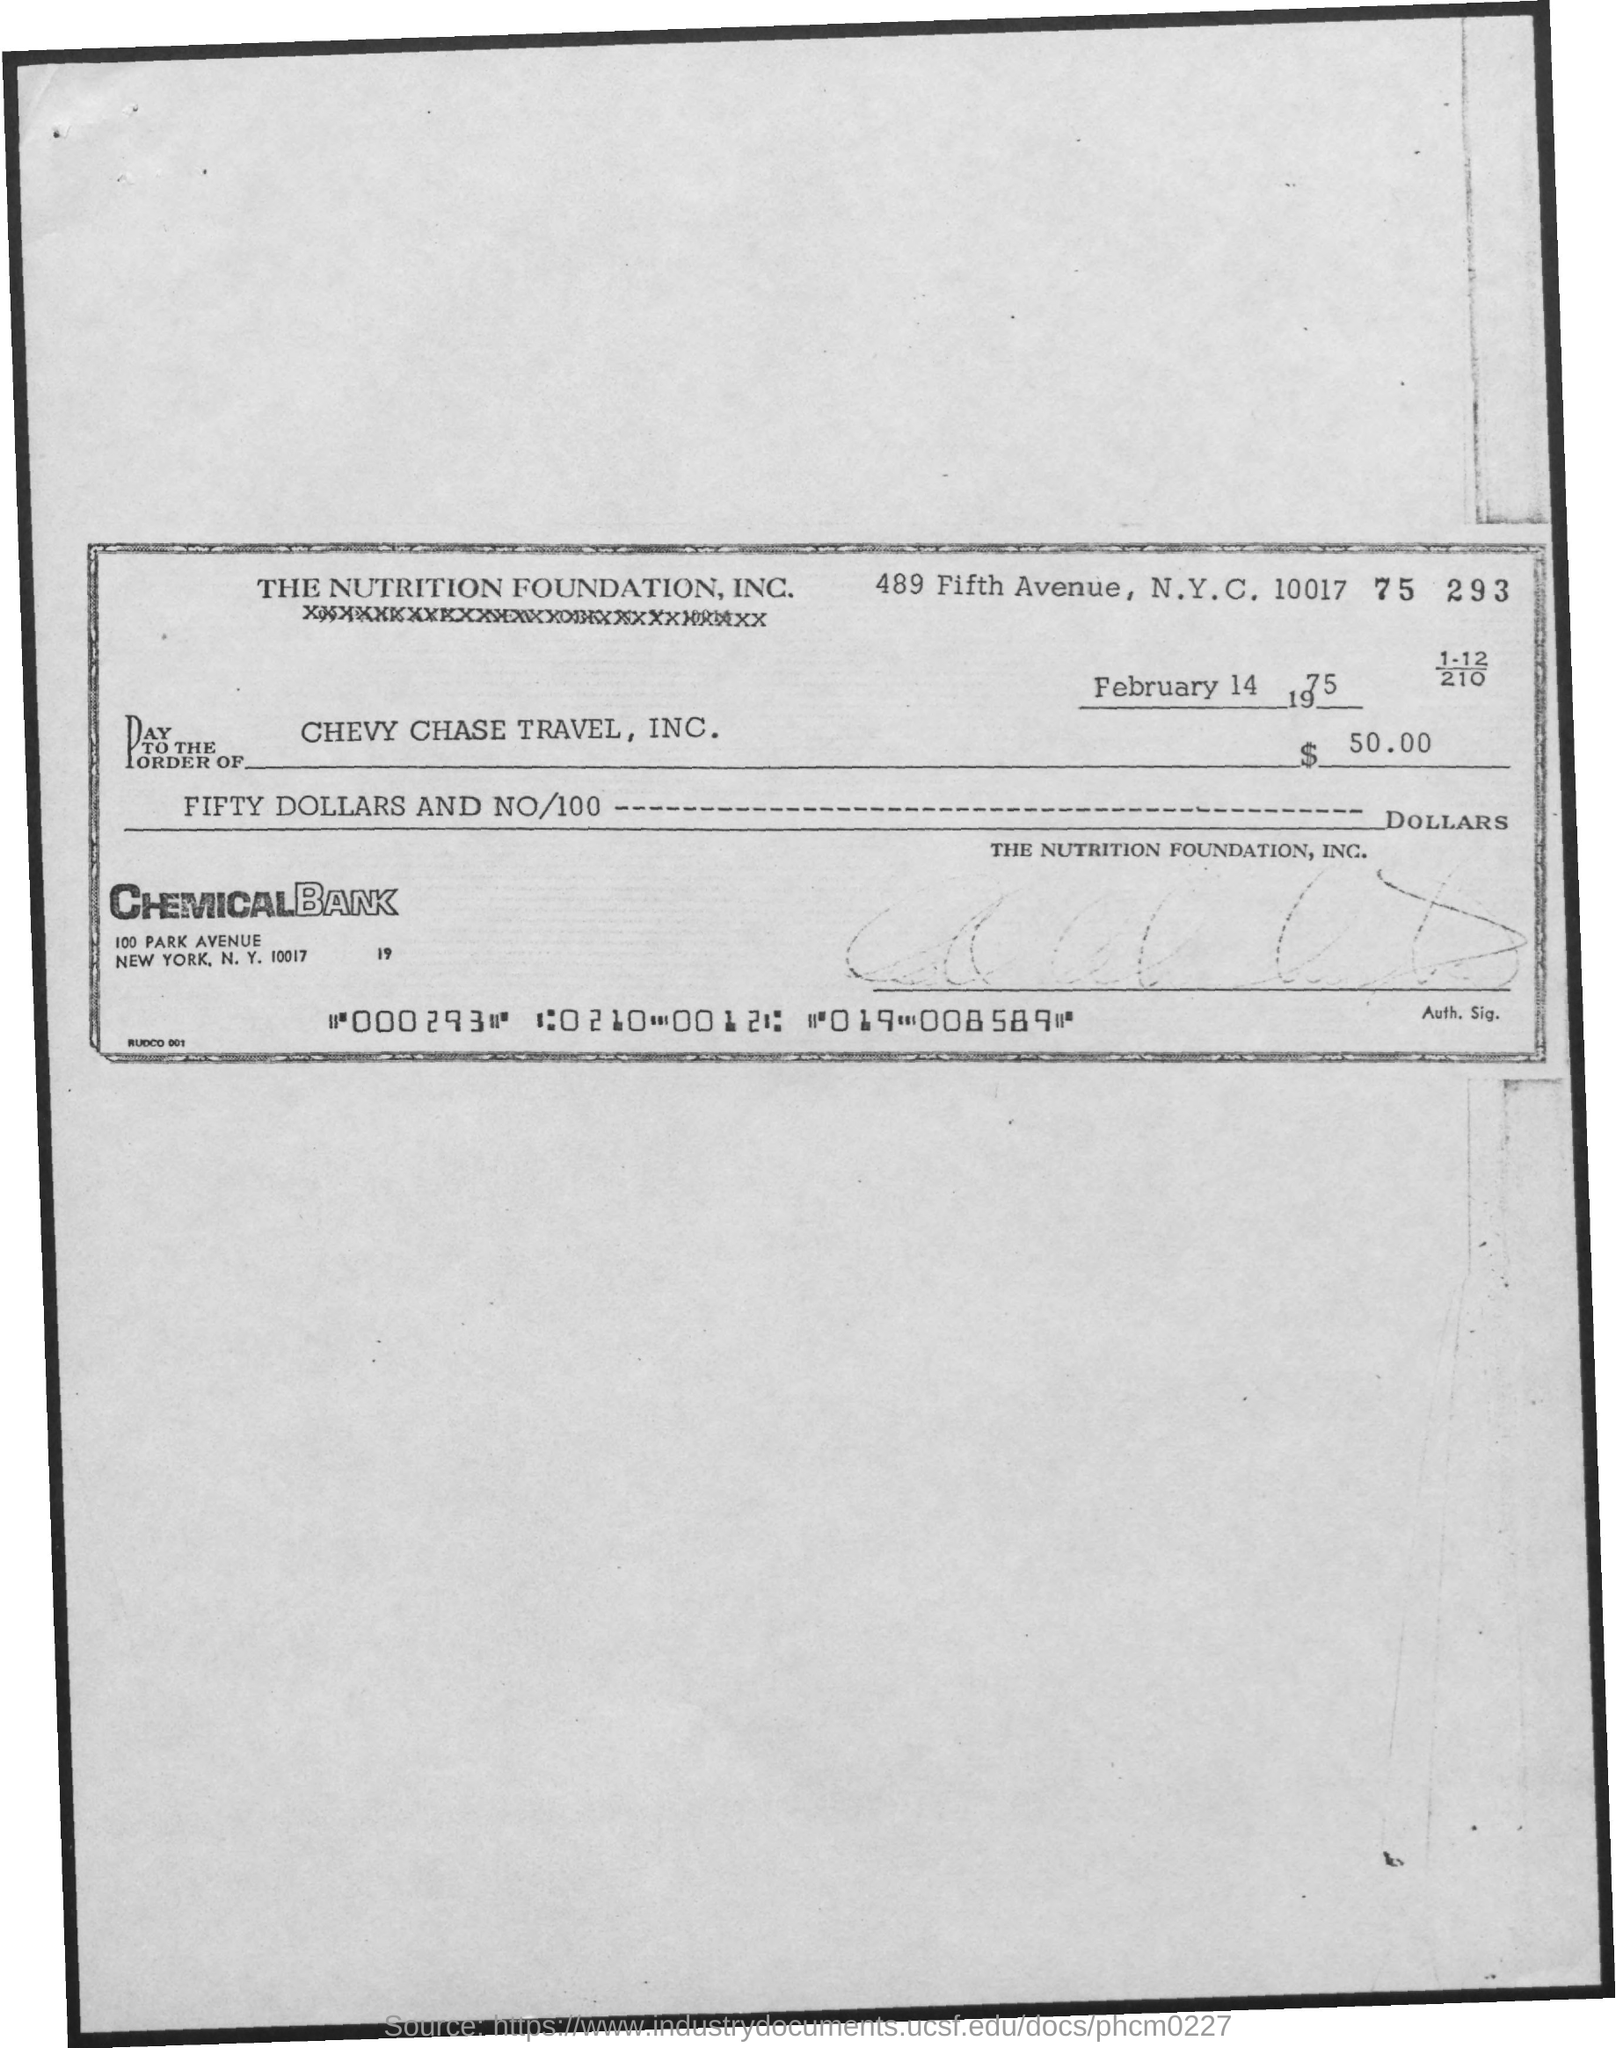Highlight a few significant elements in this photo. The bank mentioned in the document is Chemical Bank. 